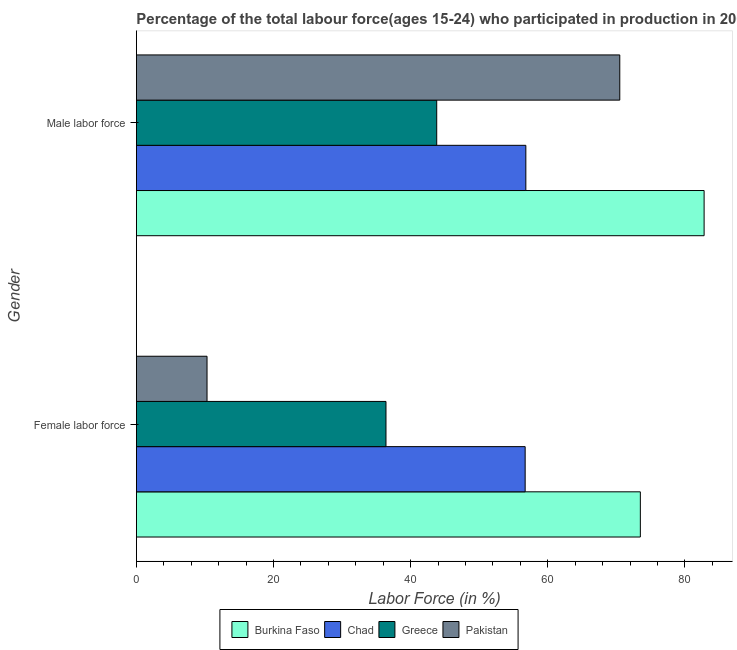How many different coloured bars are there?
Ensure brevity in your answer.  4. How many groups of bars are there?
Provide a succinct answer. 2. What is the label of the 2nd group of bars from the top?
Your answer should be compact. Female labor force. What is the percentage of male labour force in Chad?
Ensure brevity in your answer.  56.8. Across all countries, what is the maximum percentage of female labor force?
Your response must be concise. 73.5. Across all countries, what is the minimum percentage of male labour force?
Your response must be concise. 43.8. In which country was the percentage of male labour force maximum?
Give a very brief answer. Burkina Faso. In which country was the percentage of male labour force minimum?
Make the answer very short. Greece. What is the total percentage of female labor force in the graph?
Provide a succinct answer. 176.9. What is the difference between the percentage of female labor force in Chad and that in Greece?
Your answer should be very brief. 20.3. What is the difference between the percentage of female labor force in Chad and the percentage of male labour force in Pakistan?
Your answer should be very brief. -13.8. What is the average percentage of male labour force per country?
Offer a very short reply. 63.48. What is the difference between the percentage of female labor force and percentage of male labour force in Greece?
Your answer should be compact. -7.4. In how many countries, is the percentage of female labor force greater than 16 %?
Your answer should be very brief. 3. What is the ratio of the percentage of male labour force in Greece to that in Pakistan?
Your answer should be very brief. 0.62. Is the percentage of female labor force in Greece less than that in Pakistan?
Keep it short and to the point. No. What does the 4th bar from the top in Female labor force represents?
Provide a short and direct response. Burkina Faso. What does the 2nd bar from the bottom in Female labor force represents?
Provide a succinct answer. Chad. Are all the bars in the graph horizontal?
Make the answer very short. Yes. What is the difference between two consecutive major ticks on the X-axis?
Keep it short and to the point. 20. Where does the legend appear in the graph?
Your response must be concise. Bottom center. How many legend labels are there?
Provide a short and direct response. 4. How are the legend labels stacked?
Provide a succinct answer. Horizontal. What is the title of the graph?
Offer a terse response. Percentage of the total labour force(ages 15-24) who participated in production in 2000. What is the label or title of the X-axis?
Offer a very short reply. Labor Force (in %). What is the Labor Force (in %) of Burkina Faso in Female labor force?
Offer a very short reply. 73.5. What is the Labor Force (in %) of Chad in Female labor force?
Your answer should be compact. 56.7. What is the Labor Force (in %) of Greece in Female labor force?
Provide a succinct answer. 36.4. What is the Labor Force (in %) in Pakistan in Female labor force?
Keep it short and to the point. 10.3. What is the Labor Force (in %) of Burkina Faso in Male labor force?
Offer a very short reply. 82.8. What is the Labor Force (in %) of Chad in Male labor force?
Your answer should be compact. 56.8. What is the Labor Force (in %) of Greece in Male labor force?
Ensure brevity in your answer.  43.8. What is the Labor Force (in %) in Pakistan in Male labor force?
Keep it short and to the point. 70.5. Across all Gender, what is the maximum Labor Force (in %) in Burkina Faso?
Your answer should be very brief. 82.8. Across all Gender, what is the maximum Labor Force (in %) of Chad?
Provide a short and direct response. 56.8. Across all Gender, what is the maximum Labor Force (in %) of Greece?
Give a very brief answer. 43.8. Across all Gender, what is the maximum Labor Force (in %) in Pakistan?
Your answer should be very brief. 70.5. Across all Gender, what is the minimum Labor Force (in %) of Burkina Faso?
Your response must be concise. 73.5. Across all Gender, what is the minimum Labor Force (in %) in Chad?
Make the answer very short. 56.7. Across all Gender, what is the minimum Labor Force (in %) in Greece?
Your response must be concise. 36.4. Across all Gender, what is the minimum Labor Force (in %) in Pakistan?
Ensure brevity in your answer.  10.3. What is the total Labor Force (in %) of Burkina Faso in the graph?
Your answer should be compact. 156.3. What is the total Labor Force (in %) in Chad in the graph?
Your answer should be compact. 113.5. What is the total Labor Force (in %) of Greece in the graph?
Offer a terse response. 80.2. What is the total Labor Force (in %) in Pakistan in the graph?
Ensure brevity in your answer.  80.8. What is the difference between the Labor Force (in %) in Burkina Faso in Female labor force and that in Male labor force?
Provide a short and direct response. -9.3. What is the difference between the Labor Force (in %) of Chad in Female labor force and that in Male labor force?
Give a very brief answer. -0.1. What is the difference between the Labor Force (in %) in Greece in Female labor force and that in Male labor force?
Your response must be concise. -7.4. What is the difference between the Labor Force (in %) of Pakistan in Female labor force and that in Male labor force?
Make the answer very short. -60.2. What is the difference between the Labor Force (in %) in Burkina Faso in Female labor force and the Labor Force (in %) in Greece in Male labor force?
Offer a terse response. 29.7. What is the difference between the Labor Force (in %) in Chad in Female labor force and the Labor Force (in %) in Greece in Male labor force?
Give a very brief answer. 12.9. What is the difference between the Labor Force (in %) of Greece in Female labor force and the Labor Force (in %) of Pakistan in Male labor force?
Your answer should be very brief. -34.1. What is the average Labor Force (in %) in Burkina Faso per Gender?
Give a very brief answer. 78.15. What is the average Labor Force (in %) of Chad per Gender?
Your answer should be very brief. 56.75. What is the average Labor Force (in %) of Greece per Gender?
Your response must be concise. 40.1. What is the average Labor Force (in %) of Pakistan per Gender?
Your response must be concise. 40.4. What is the difference between the Labor Force (in %) of Burkina Faso and Labor Force (in %) of Chad in Female labor force?
Make the answer very short. 16.8. What is the difference between the Labor Force (in %) of Burkina Faso and Labor Force (in %) of Greece in Female labor force?
Provide a succinct answer. 37.1. What is the difference between the Labor Force (in %) of Burkina Faso and Labor Force (in %) of Pakistan in Female labor force?
Offer a very short reply. 63.2. What is the difference between the Labor Force (in %) of Chad and Labor Force (in %) of Greece in Female labor force?
Ensure brevity in your answer.  20.3. What is the difference between the Labor Force (in %) in Chad and Labor Force (in %) in Pakistan in Female labor force?
Provide a short and direct response. 46.4. What is the difference between the Labor Force (in %) of Greece and Labor Force (in %) of Pakistan in Female labor force?
Offer a terse response. 26.1. What is the difference between the Labor Force (in %) of Burkina Faso and Labor Force (in %) of Pakistan in Male labor force?
Your answer should be very brief. 12.3. What is the difference between the Labor Force (in %) in Chad and Labor Force (in %) in Greece in Male labor force?
Provide a short and direct response. 13. What is the difference between the Labor Force (in %) in Chad and Labor Force (in %) in Pakistan in Male labor force?
Your answer should be compact. -13.7. What is the difference between the Labor Force (in %) of Greece and Labor Force (in %) of Pakistan in Male labor force?
Ensure brevity in your answer.  -26.7. What is the ratio of the Labor Force (in %) of Burkina Faso in Female labor force to that in Male labor force?
Your answer should be compact. 0.89. What is the ratio of the Labor Force (in %) of Chad in Female labor force to that in Male labor force?
Your answer should be compact. 1. What is the ratio of the Labor Force (in %) of Greece in Female labor force to that in Male labor force?
Give a very brief answer. 0.83. What is the ratio of the Labor Force (in %) in Pakistan in Female labor force to that in Male labor force?
Your answer should be very brief. 0.15. What is the difference between the highest and the second highest Labor Force (in %) in Chad?
Ensure brevity in your answer.  0.1. What is the difference between the highest and the second highest Labor Force (in %) in Greece?
Keep it short and to the point. 7.4. What is the difference between the highest and the second highest Labor Force (in %) in Pakistan?
Your response must be concise. 60.2. What is the difference between the highest and the lowest Labor Force (in %) of Burkina Faso?
Offer a very short reply. 9.3. What is the difference between the highest and the lowest Labor Force (in %) in Pakistan?
Provide a succinct answer. 60.2. 